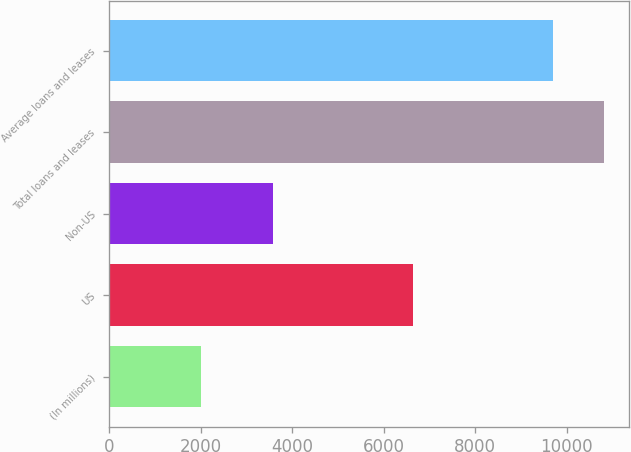Convert chart to OTSL. <chart><loc_0><loc_0><loc_500><loc_500><bar_chart><fcel>(In millions)<fcel>US<fcel>Non-US<fcel>Total loans and leases<fcel>Average loans and leases<nl><fcel>2009<fcel>6637<fcel>3571<fcel>10808<fcel>9703<nl></chart> 